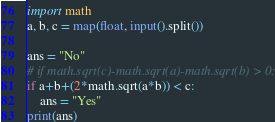<code> <loc_0><loc_0><loc_500><loc_500><_Python_>import math
a, b, c = map(float, input().split())

ans = "No"
# if math.sqrt(c)-math.sqrt(a)-math.sqrt(b) > 0:
if a+b+(2*math.sqrt(a*b)) < c:
    ans = "Yes"
print(ans)
</code> 